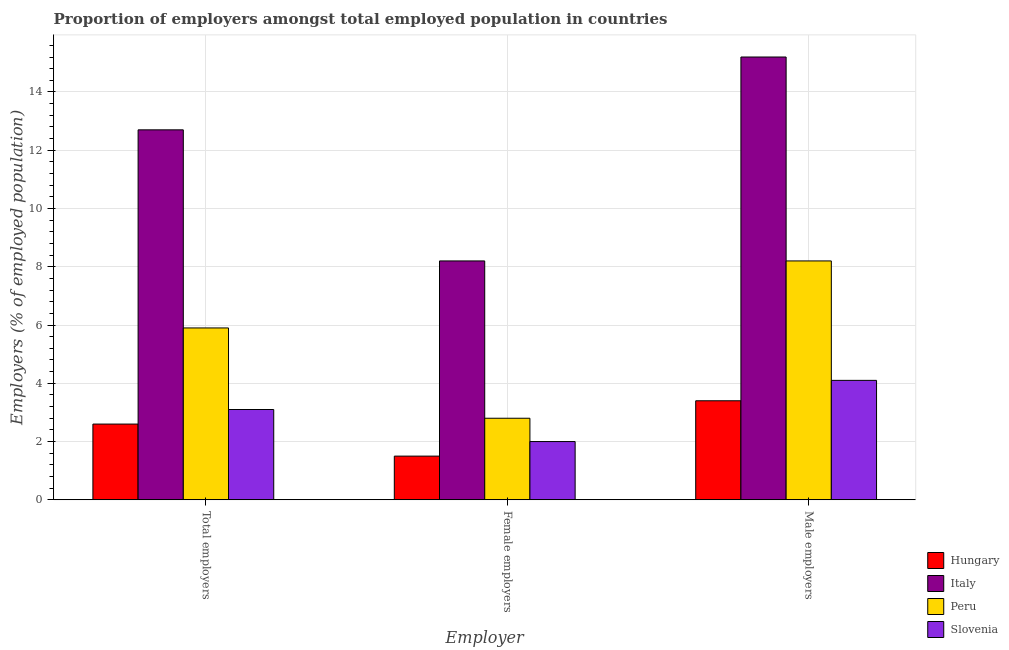How many different coloured bars are there?
Provide a short and direct response. 4. Are the number of bars on each tick of the X-axis equal?
Your answer should be compact. Yes. What is the label of the 1st group of bars from the left?
Offer a very short reply. Total employers. What is the percentage of total employers in Peru?
Your answer should be compact. 5.9. Across all countries, what is the maximum percentage of female employers?
Ensure brevity in your answer.  8.2. Across all countries, what is the minimum percentage of male employers?
Provide a succinct answer. 3.4. In which country was the percentage of total employers minimum?
Offer a very short reply. Hungary. What is the total percentage of female employers in the graph?
Offer a very short reply. 14.5. What is the difference between the percentage of male employers in Peru and that in Slovenia?
Provide a short and direct response. 4.1. What is the difference between the percentage of total employers in Slovenia and the percentage of male employers in Italy?
Ensure brevity in your answer.  -12.1. What is the average percentage of female employers per country?
Keep it short and to the point. 3.62. What is the difference between the percentage of male employers and percentage of total employers in Slovenia?
Your answer should be very brief. 1. In how many countries, is the percentage of male employers greater than 7.2 %?
Your answer should be compact. 2. What is the ratio of the percentage of total employers in Slovenia to that in Peru?
Ensure brevity in your answer.  0.53. Is the difference between the percentage of female employers in Slovenia and Peru greater than the difference between the percentage of total employers in Slovenia and Peru?
Keep it short and to the point. Yes. What is the difference between the highest and the second highest percentage of total employers?
Provide a succinct answer. 6.8. What is the difference between the highest and the lowest percentage of total employers?
Offer a terse response. 10.1. In how many countries, is the percentage of female employers greater than the average percentage of female employers taken over all countries?
Offer a very short reply. 1. What does the 1st bar from the left in Total employers represents?
Give a very brief answer. Hungary. What does the 4th bar from the right in Total employers represents?
Your answer should be compact. Hungary. How many bars are there?
Offer a very short reply. 12. What is the difference between two consecutive major ticks on the Y-axis?
Give a very brief answer. 2. Are the values on the major ticks of Y-axis written in scientific E-notation?
Offer a very short reply. No. Does the graph contain grids?
Give a very brief answer. Yes. How many legend labels are there?
Offer a very short reply. 4. What is the title of the graph?
Make the answer very short. Proportion of employers amongst total employed population in countries. Does "Middle income" appear as one of the legend labels in the graph?
Provide a short and direct response. No. What is the label or title of the X-axis?
Provide a short and direct response. Employer. What is the label or title of the Y-axis?
Give a very brief answer. Employers (% of employed population). What is the Employers (% of employed population) of Hungary in Total employers?
Make the answer very short. 2.6. What is the Employers (% of employed population) of Italy in Total employers?
Keep it short and to the point. 12.7. What is the Employers (% of employed population) in Peru in Total employers?
Your answer should be very brief. 5.9. What is the Employers (% of employed population) of Slovenia in Total employers?
Provide a succinct answer. 3.1. What is the Employers (% of employed population) of Hungary in Female employers?
Make the answer very short. 1.5. What is the Employers (% of employed population) in Italy in Female employers?
Keep it short and to the point. 8.2. What is the Employers (% of employed population) of Peru in Female employers?
Offer a terse response. 2.8. What is the Employers (% of employed population) in Hungary in Male employers?
Keep it short and to the point. 3.4. What is the Employers (% of employed population) in Italy in Male employers?
Your answer should be very brief. 15.2. What is the Employers (% of employed population) in Peru in Male employers?
Offer a very short reply. 8.2. What is the Employers (% of employed population) of Slovenia in Male employers?
Your answer should be very brief. 4.1. Across all Employer, what is the maximum Employers (% of employed population) in Hungary?
Keep it short and to the point. 3.4. Across all Employer, what is the maximum Employers (% of employed population) of Italy?
Your answer should be very brief. 15.2. Across all Employer, what is the maximum Employers (% of employed population) of Peru?
Offer a terse response. 8.2. Across all Employer, what is the maximum Employers (% of employed population) in Slovenia?
Provide a short and direct response. 4.1. Across all Employer, what is the minimum Employers (% of employed population) in Hungary?
Your answer should be very brief. 1.5. Across all Employer, what is the minimum Employers (% of employed population) of Italy?
Offer a terse response. 8.2. Across all Employer, what is the minimum Employers (% of employed population) in Peru?
Keep it short and to the point. 2.8. What is the total Employers (% of employed population) of Hungary in the graph?
Offer a terse response. 7.5. What is the total Employers (% of employed population) in Italy in the graph?
Offer a terse response. 36.1. What is the total Employers (% of employed population) in Peru in the graph?
Offer a terse response. 16.9. What is the total Employers (% of employed population) in Slovenia in the graph?
Keep it short and to the point. 9.2. What is the difference between the Employers (% of employed population) of Hungary in Total employers and that in Female employers?
Give a very brief answer. 1.1. What is the difference between the Employers (% of employed population) in Italy in Total employers and that in Male employers?
Provide a short and direct response. -2.5. What is the difference between the Employers (% of employed population) in Italy in Total employers and the Employers (% of employed population) in Peru in Female employers?
Your answer should be very brief. 9.9. What is the difference between the Employers (% of employed population) of Peru in Total employers and the Employers (% of employed population) of Slovenia in Female employers?
Provide a succinct answer. 3.9. What is the difference between the Employers (% of employed population) of Hungary in Total employers and the Employers (% of employed population) of Slovenia in Male employers?
Make the answer very short. -1.5. What is the difference between the Employers (% of employed population) of Italy in Total employers and the Employers (% of employed population) of Peru in Male employers?
Offer a terse response. 4.5. What is the difference between the Employers (% of employed population) of Italy in Total employers and the Employers (% of employed population) of Slovenia in Male employers?
Your answer should be compact. 8.6. What is the difference between the Employers (% of employed population) in Hungary in Female employers and the Employers (% of employed population) in Italy in Male employers?
Your answer should be compact. -13.7. What is the difference between the Employers (% of employed population) in Hungary in Female employers and the Employers (% of employed population) in Peru in Male employers?
Provide a succinct answer. -6.7. What is the difference between the Employers (% of employed population) of Italy in Female employers and the Employers (% of employed population) of Peru in Male employers?
Your answer should be very brief. 0. What is the difference between the Employers (% of employed population) in Italy in Female employers and the Employers (% of employed population) in Slovenia in Male employers?
Keep it short and to the point. 4.1. What is the difference between the Employers (% of employed population) of Peru in Female employers and the Employers (% of employed population) of Slovenia in Male employers?
Keep it short and to the point. -1.3. What is the average Employers (% of employed population) of Hungary per Employer?
Keep it short and to the point. 2.5. What is the average Employers (% of employed population) of Italy per Employer?
Keep it short and to the point. 12.03. What is the average Employers (% of employed population) of Peru per Employer?
Your response must be concise. 5.63. What is the average Employers (% of employed population) in Slovenia per Employer?
Make the answer very short. 3.07. What is the difference between the Employers (% of employed population) of Hungary and Employers (% of employed population) of Italy in Total employers?
Ensure brevity in your answer.  -10.1. What is the difference between the Employers (% of employed population) in Hungary and Employers (% of employed population) in Slovenia in Total employers?
Offer a very short reply. -0.5. What is the difference between the Employers (% of employed population) in Italy and Employers (% of employed population) in Peru in Total employers?
Give a very brief answer. 6.8. What is the difference between the Employers (% of employed population) in Hungary and Employers (% of employed population) in Slovenia in Female employers?
Your response must be concise. -0.5. What is the difference between the Employers (% of employed population) of Italy and Employers (% of employed population) of Slovenia in Female employers?
Make the answer very short. 6.2. What is the difference between the Employers (% of employed population) in Hungary and Employers (% of employed population) in Italy in Male employers?
Provide a short and direct response. -11.8. What is the difference between the Employers (% of employed population) of Hungary and Employers (% of employed population) of Slovenia in Male employers?
Ensure brevity in your answer.  -0.7. What is the difference between the Employers (% of employed population) in Italy and Employers (% of employed population) in Slovenia in Male employers?
Your response must be concise. 11.1. What is the difference between the Employers (% of employed population) of Peru and Employers (% of employed population) of Slovenia in Male employers?
Your response must be concise. 4.1. What is the ratio of the Employers (% of employed population) of Hungary in Total employers to that in Female employers?
Keep it short and to the point. 1.73. What is the ratio of the Employers (% of employed population) of Italy in Total employers to that in Female employers?
Give a very brief answer. 1.55. What is the ratio of the Employers (% of employed population) of Peru in Total employers to that in Female employers?
Your answer should be compact. 2.11. What is the ratio of the Employers (% of employed population) of Slovenia in Total employers to that in Female employers?
Offer a terse response. 1.55. What is the ratio of the Employers (% of employed population) of Hungary in Total employers to that in Male employers?
Keep it short and to the point. 0.76. What is the ratio of the Employers (% of employed population) of Italy in Total employers to that in Male employers?
Ensure brevity in your answer.  0.84. What is the ratio of the Employers (% of employed population) in Peru in Total employers to that in Male employers?
Provide a short and direct response. 0.72. What is the ratio of the Employers (% of employed population) in Slovenia in Total employers to that in Male employers?
Offer a very short reply. 0.76. What is the ratio of the Employers (% of employed population) of Hungary in Female employers to that in Male employers?
Keep it short and to the point. 0.44. What is the ratio of the Employers (% of employed population) of Italy in Female employers to that in Male employers?
Provide a short and direct response. 0.54. What is the ratio of the Employers (% of employed population) in Peru in Female employers to that in Male employers?
Your answer should be very brief. 0.34. What is the ratio of the Employers (% of employed population) in Slovenia in Female employers to that in Male employers?
Offer a terse response. 0.49. What is the difference between the highest and the second highest Employers (% of employed population) in Hungary?
Provide a succinct answer. 0.8. What is the difference between the highest and the second highest Employers (% of employed population) of Italy?
Give a very brief answer. 2.5. What is the difference between the highest and the second highest Employers (% of employed population) of Peru?
Provide a short and direct response. 2.3. What is the difference between the highest and the lowest Employers (% of employed population) in Hungary?
Keep it short and to the point. 1.9. What is the difference between the highest and the lowest Employers (% of employed population) of Slovenia?
Make the answer very short. 2.1. 